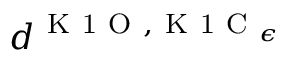Convert formula to latex. <formula><loc_0><loc_0><loc_500><loc_500>d ^ { K 1 O , K 1 C _ { \epsilon } }</formula> 